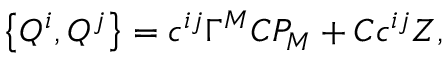Convert formula to latex. <formula><loc_0><loc_0><loc_500><loc_500>\left \{ Q ^ { i } , Q ^ { j } \right \} = c ^ { i j } \Gamma ^ { M } C P _ { M } + C c ^ { i j } Z ,</formula> 